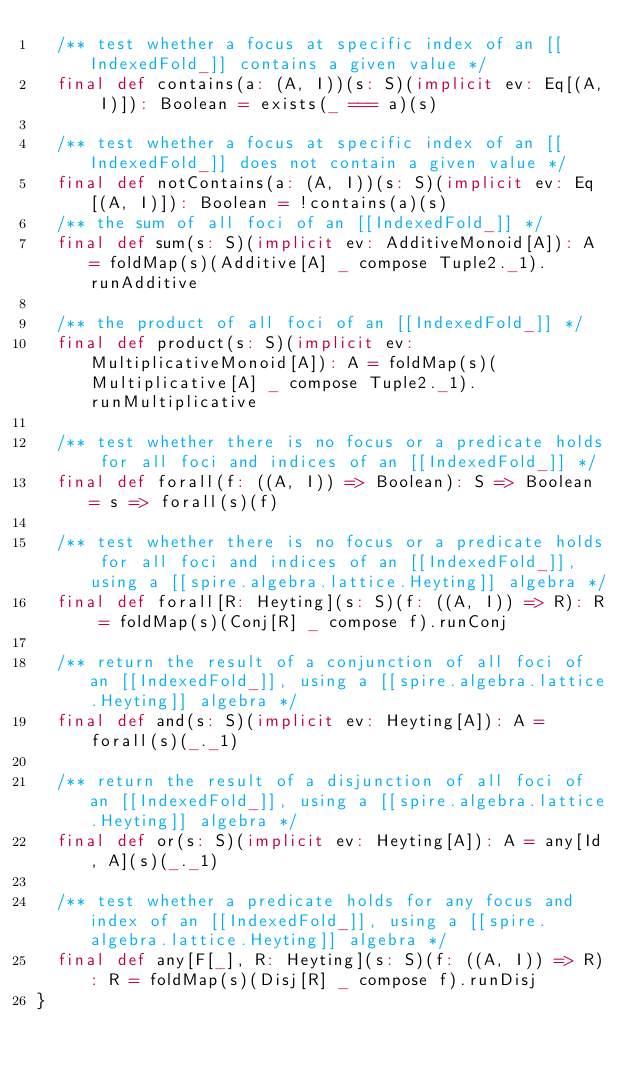<code> <loc_0><loc_0><loc_500><loc_500><_Scala_>  /** test whether a focus at specific index of an [[IndexedFold_]] contains a given value */
  final def contains(a: (A, I))(s: S)(implicit ev: Eq[(A, I)]): Boolean = exists(_ === a)(s)

  /** test whether a focus at specific index of an [[IndexedFold_]] does not contain a given value */
  final def notContains(a: (A, I))(s: S)(implicit ev: Eq[(A, I)]): Boolean = !contains(a)(s)
  /** the sum of all foci of an [[IndexedFold_]] */
  final def sum(s: S)(implicit ev: AdditiveMonoid[A]): A = foldMap(s)(Additive[A] _ compose Tuple2._1).runAdditive

  /** the product of all foci of an [[IndexedFold_]] */
  final def product(s: S)(implicit ev: MultiplicativeMonoid[A]): A = foldMap(s)(Multiplicative[A] _ compose Tuple2._1).runMultiplicative

  /** test whether there is no focus or a predicate holds for all foci and indices of an [[IndexedFold_]] */
  final def forall(f: ((A, I)) => Boolean): S => Boolean = s => forall(s)(f)

  /** test whether there is no focus or a predicate holds for all foci and indices of an [[IndexedFold_]], using a [[spire.algebra.lattice.Heyting]] algebra */
  final def forall[R: Heyting](s: S)(f: ((A, I)) => R): R = foldMap(s)(Conj[R] _ compose f).runConj

  /** return the result of a conjunction of all foci of an [[IndexedFold_]], using a [[spire.algebra.lattice.Heyting]] algebra */
  final def and(s: S)(implicit ev: Heyting[A]): A = forall(s)(_._1)

  /** return the result of a disjunction of all foci of an [[IndexedFold_]], using a [[spire.algebra.lattice.Heyting]] algebra */
  final def or(s: S)(implicit ev: Heyting[A]): A = any[Id, A](s)(_._1)

  /** test whether a predicate holds for any focus and index of an [[IndexedFold_]], using a [[spire.algebra.lattice.Heyting]] algebra */
  final def any[F[_], R: Heyting](s: S)(f: ((A, I)) => R): R = foldMap(s)(Disj[R] _ compose f).runDisj
}
</code> 